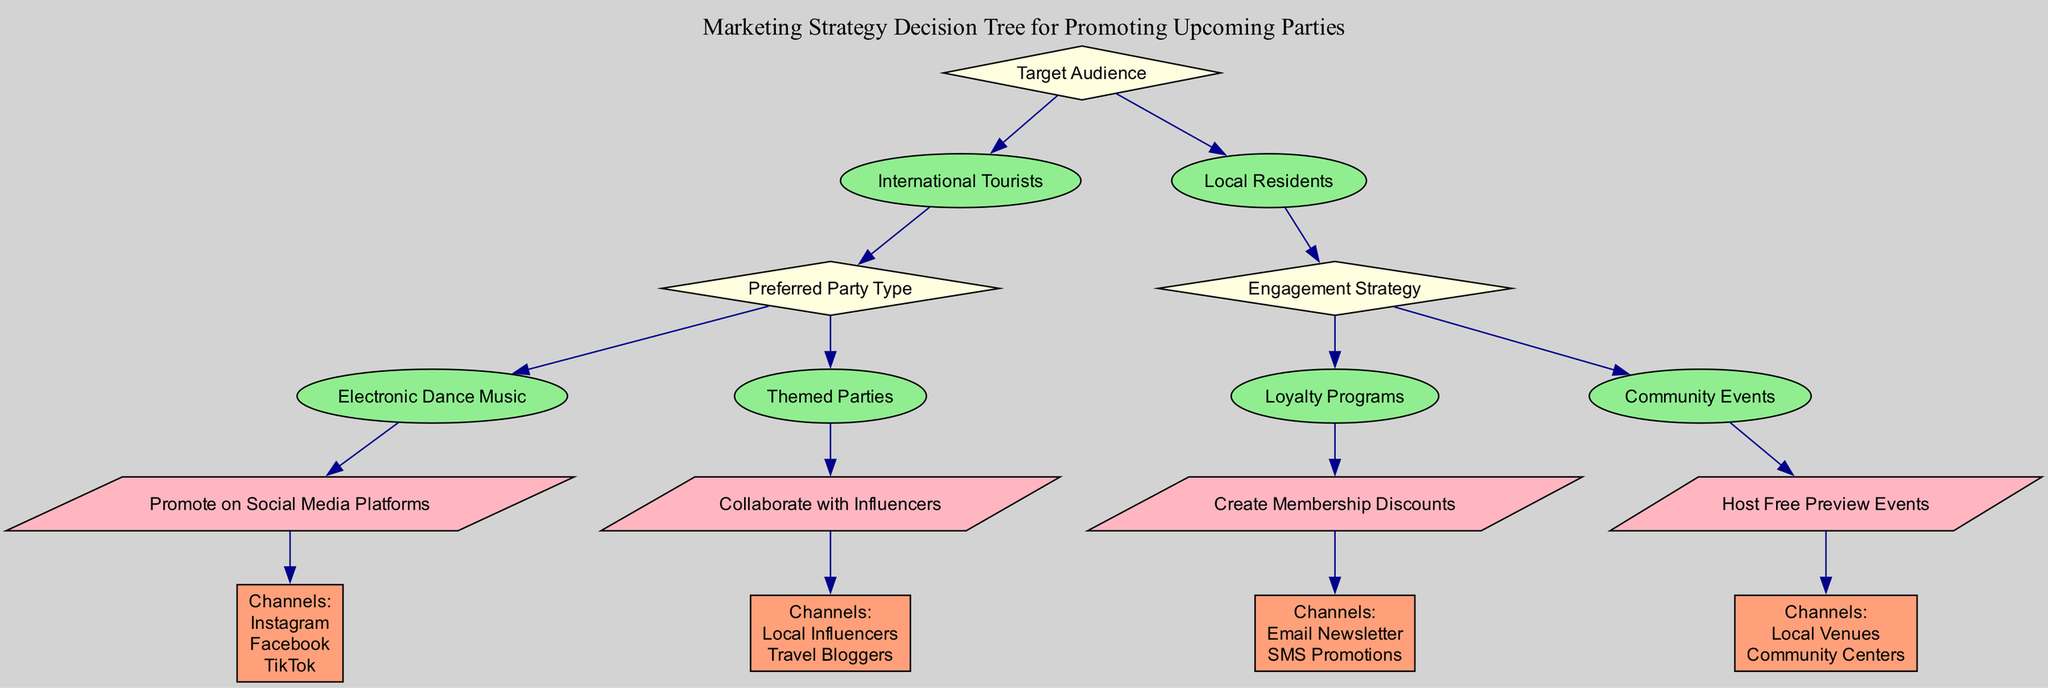What is the first decision in the tree? The first decision node in the tree is "Target Audience." This is located directly at the top of the diagram.
Answer: Target Audience How many options are there under "International Tourists"? Under "International Tourists," there are two options: "Electronic Dance Music" and "Themed Parties." This can be counted from the visible branches in the diagram.
Answer: 2 What action should be taken for "Themed Parties"? The action associated with "Themed Parties" is "Collaborate with Influencers," which is clearly indicated in the tree as the next step after the option is chosen.
Answer: Collaborate with Influencers Which channels are suggested for "Create Membership Discounts"? The channels listed for "Create Membership Discounts" are "Email Newsletter" and "SMS Promotions," as detailed in the channel node connected to the action in the tree.
Answer: Email Newsletter, SMS Promotions What is the flow of action if the target audience is "Local Residents"? If the target audience is "Local Residents," the next decision is "Engagement Strategy." Depending on the engagement strategy chosen, there are further actions: either "Create Membership Discounts" or "Host Free Preview Events." Therefore, two distinct paths can be followed based on the engagement strategy selected by the locals.
Answer: Engagement Strategy Which decision leads to an action involving social media? The decision "International Tourists" followed by "Electronic Dance Music" leads to the action "Promote on Social Media Platforms." This can be traced through the options visible in the decision tree.
Answer: International Tourists -> Electronic Dance Music What is the total number of nodes in the diagram? The total number of nodes includes the decision nodes, action nodes, and channel nodes. Counting them provides a total of eight nodes in the entire diagram.
Answer: 8 What type of strategy is suggested for "Community Events"? The strategy suggested for "Community Events" is to "Host Free Preview Events," indicated directly under the corresponding engagement strategy node in the decision tree.
Answer: Host Free Preview Events 